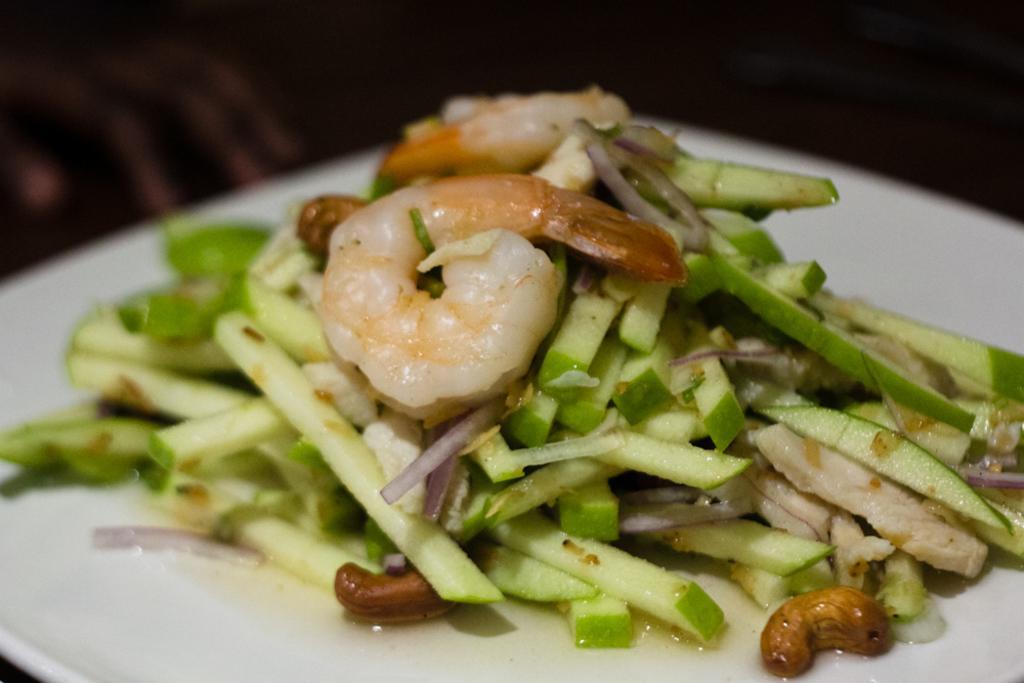Please provide a concise description of this image. This image consists of food which is on the plate in the center and the background is blurry. 